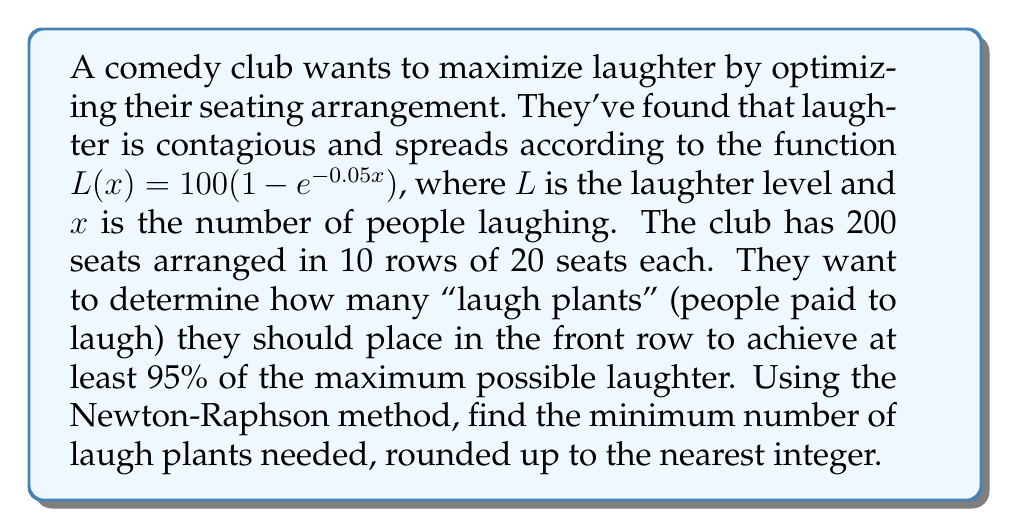Help me with this question. 1) First, we need to set up our equation:
   $L(x) = 100(1 - e^{-0.05x}) = 95$

2) Rearranging this:
   $1 - e^{-0.05x} = 0.95$
   $e^{-0.05x} = 0.05$
   $-0.05x = \ln(0.05)$
   $x = -\frac{\ln(0.05)}{0.05}$

3) Let's define our function $f(x)$ and its derivative $f'(x)$:
   $f(x) = 100(1 - e^{-0.05x}) - 95$
   $f'(x) = 5e^{-0.05x}$

4) Now we apply the Newton-Raphson method:
   $x_{n+1} = x_n - \frac{f(x_n)}{f'(x_n)}$

5) Let's start with $x_0 = 20$ (a reasonable guess):

   $x_1 = 20 - \frac{100(1 - e^{-0.05(20)}) - 95}{5e^{-0.05(20)}} \approx 59.91$

   $x_2 = 59.91 - \frac{100(1 - e^{-0.05(59.91)}) - 95}{5e^{-0.05(59.91)}} \approx 59.91$

6) The method converges quickly to 59.91.

7) Rounding up to the nearest integer gives us 60.
Answer: 60 laugh plants 